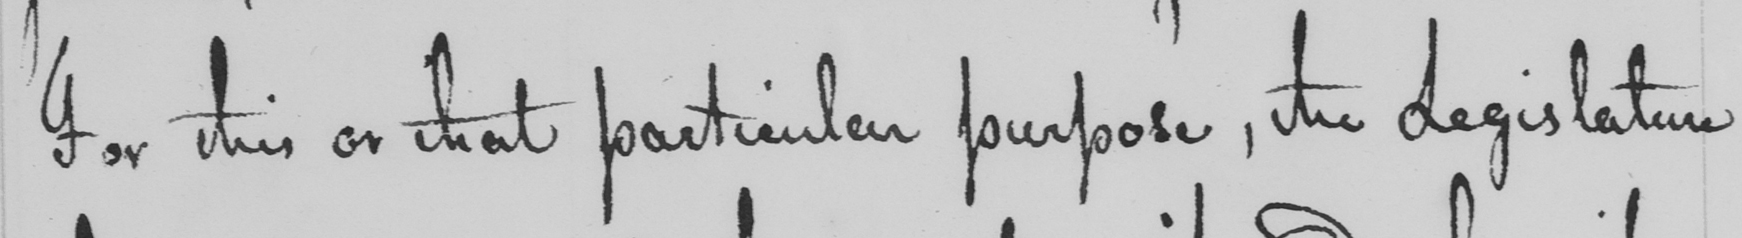Transcribe the text shown in this historical manuscript line. For this or that particular purpose , the Legislature 